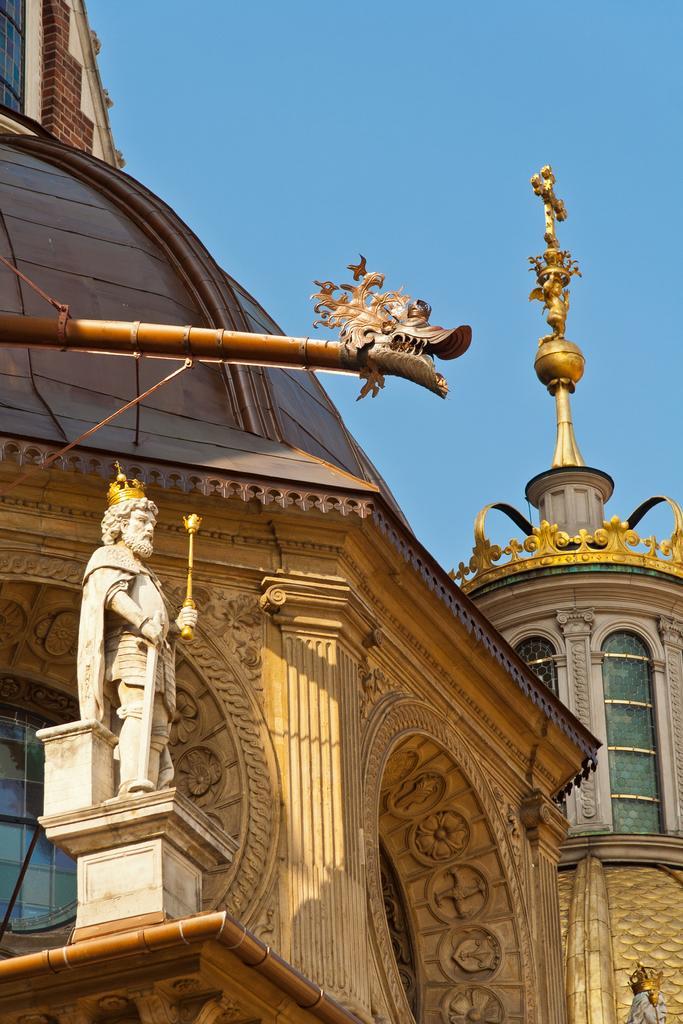Could you give a brief overview of what you see in this image? As we can see in the image there are buildings, windows, statue and sky. 